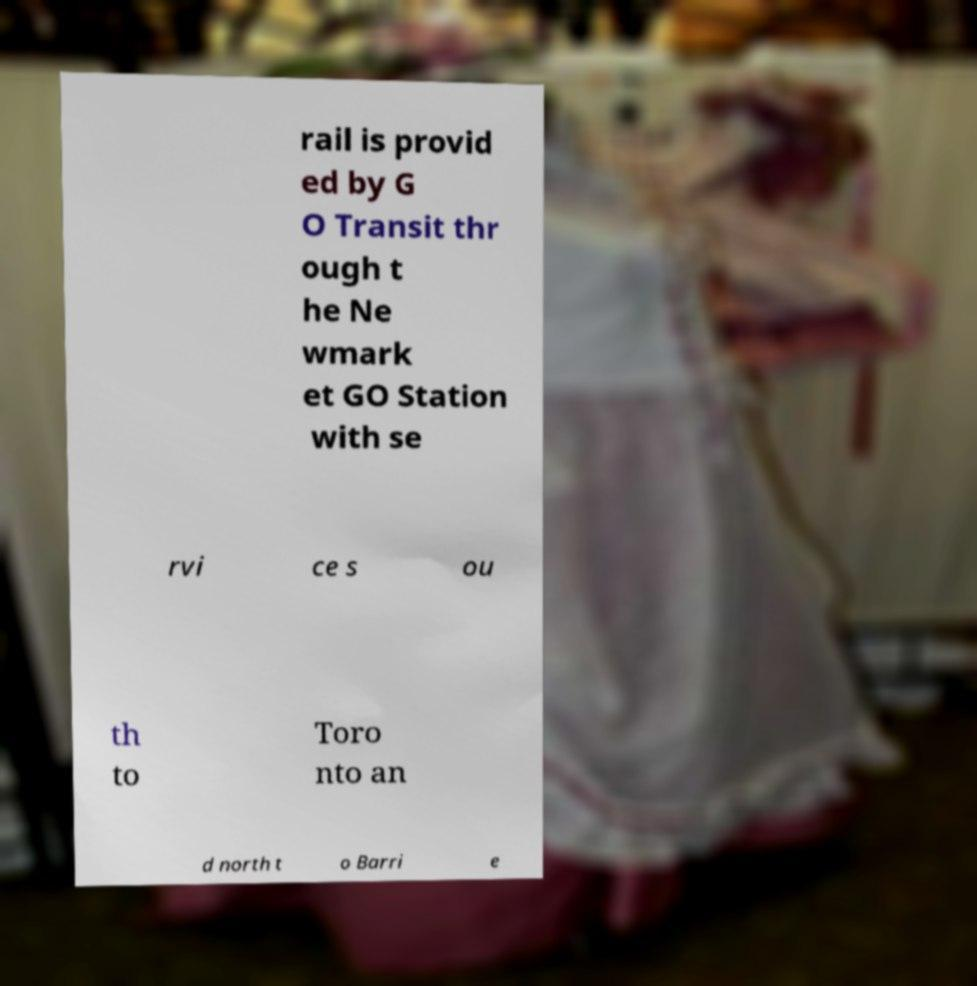There's text embedded in this image that I need extracted. Can you transcribe it verbatim? rail is provid ed by G O Transit thr ough t he Ne wmark et GO Station with se rvi ce s ou th to Toro nto an d north t o Barri e 